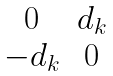Convert formula to latex. <formula><loc_0><loc_0><loc_500><loc_500>\begin{matrix} 0 & d _ { k } \\ - d _ { k } & 0 \end{matrix}</formula> 